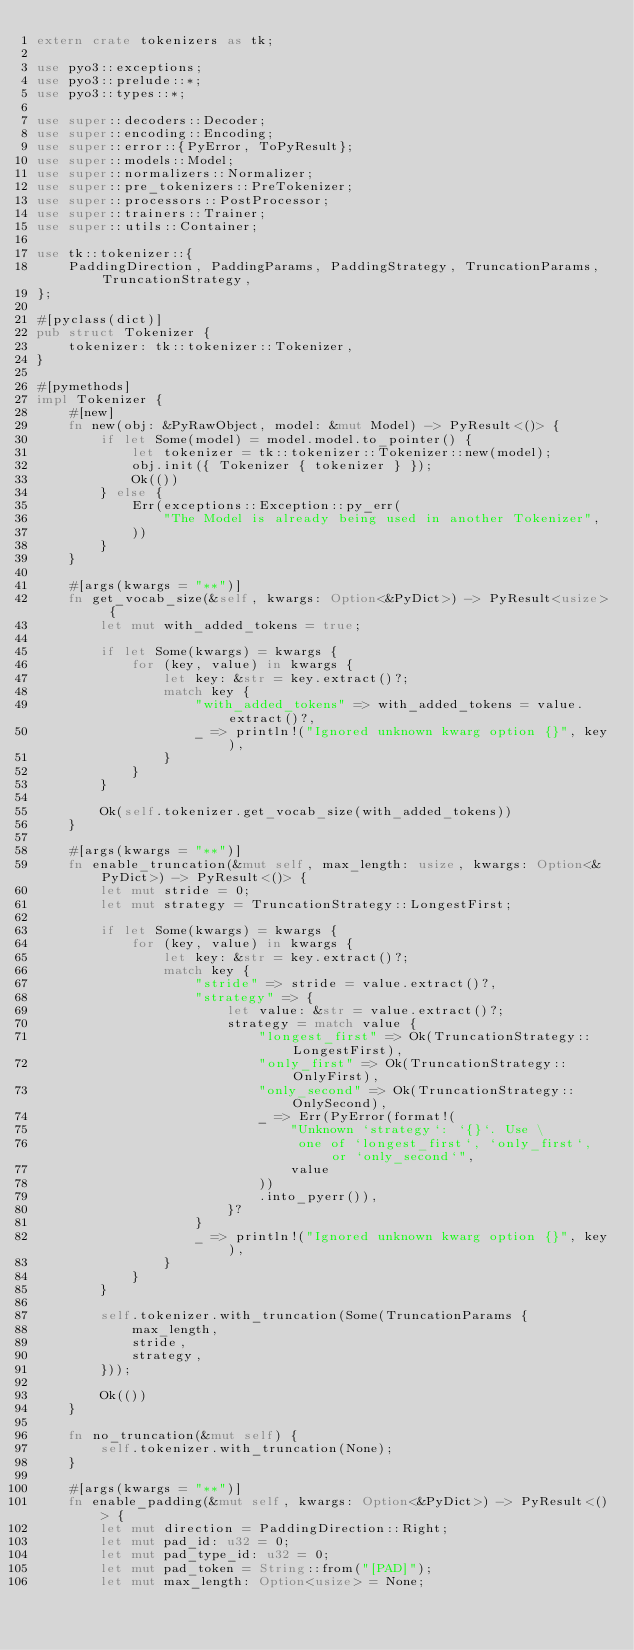Convert code to text. <code><loc_0><loc_0><loc_500><loc_500><_Rust_>extern crate tokenizers as tk;

use pyo3::exceptions;
use pyo3::prelude::*;
use pyo3::types::*;

use super::decoders::Decoder;
use super::encoding::Encoding;
use super::error::{PyError, ToPyResult};
use super::models::Model;
use super::normalizers::Normalizer;
use super::pre_tokenizers::PreTokenizer;
use super::processors::PostProcessor;
use super::trainers::Trainer;
use super::utils::Container;

use tk::tokenizer::{
    PaddingDirection, PaddingParams, PaddingStrategy, TruncationParams, TruncationStrategy,
};

#[pyclass(dict)]
pub struct Tokenizer {
    tokenizer: tk::tokenizer::Tokenizer,
}

#[pymethods]
impl Tokenizer {
    #[new]
    fn new(obj: &PyRawObject, model: &mut Model) -> PyResult<()> {
        if let Some(model) = model.model.to_pointer() {
            let tokenizer = tk::tokenizer::Tokenizer::new(model);
            obj.init({ Tokenizer { tokenizer } });
            Ok(())
        } else {
            Err(exceptions::Exception::py_err(
                "The Model is already being used in another Tokenizer",
            ))
        }
    }

    #[args(kwargs = "**")]
    fn get_vocab_size(&self, kwargs: Option<&PyDict>) -> PyResult<usize> {
        let mut with_added_tokens = true;

        if let Some(kwargs) = kwargs {
            for (key, value) in kwargs {
                let key: &str = key.extract()?;
                match key {
                    "with_added_tokens" => with_added_tokens = value.extract()?,
                    _ => println!("Ignored unknown kwarg option {}", key),
                }
            }
        }

        Ok(self.tokenizer.get_vocab_size(with_added_tokens))
    }

    #[args(kwargs = "**")]
    fn enable_truncation(&mut self, max_length: usize, kwargs: Option<&PyDict>) -> PyResult<()> {
        let mut stride = 0;
        let mut strategy = TruncationStrategy::LongestFirst;

        if let Some(kwargs) = kwargs {
            for (key, value) in kwargs {
                let key: &str = key.extract()?;
                match key {
                    "stride" => stride = value.extract()?,
                    "strategy" => {
                        let value: &str = value.extract()?;
                        strategy = match value {
                            "longest_first" => Ok(TruncationStrategy::LongestFirst),
                            "only_first" => Ok(TruncationStrategy::OnlyFirst),
                            "only_second" => Ok(TruncationStrategy::OnlySecond),
                            _ => Err(PyError(format!(
                                "Unknown `strategy`: `{}`. Use \
                                 one of `longest_first`, `only_first`, or `only_second`",
                                value
                            ))
                            .into_pyerr()),
                        }?
                    }
                    _ => println!("Ignored unknown kwarg option {}", key),
                }
            }
        }

        self.tokenizer.with_truncation(Some(TruncationParams {
            max_length,
            stride,
            strategy,
        }));

        Ok(())
    }

    fn no_truncation(&mut self) {
        self.tokenizer.with_truncation(None);
    }

    #[args(kwargs = "**")]
    fn enable_padding(&mut self, kwargs: Option<&PyDict>) -> PyResult<()> {
        let mut direction = PaddingDirection::Right;
        let mut pad_id: u32 = 0;
        let mut pad_type_id: u32 = 0;
        let mut pad_token = String::from("[PAD]");
        let mut max_length: Option<usize> = None;
</code> 